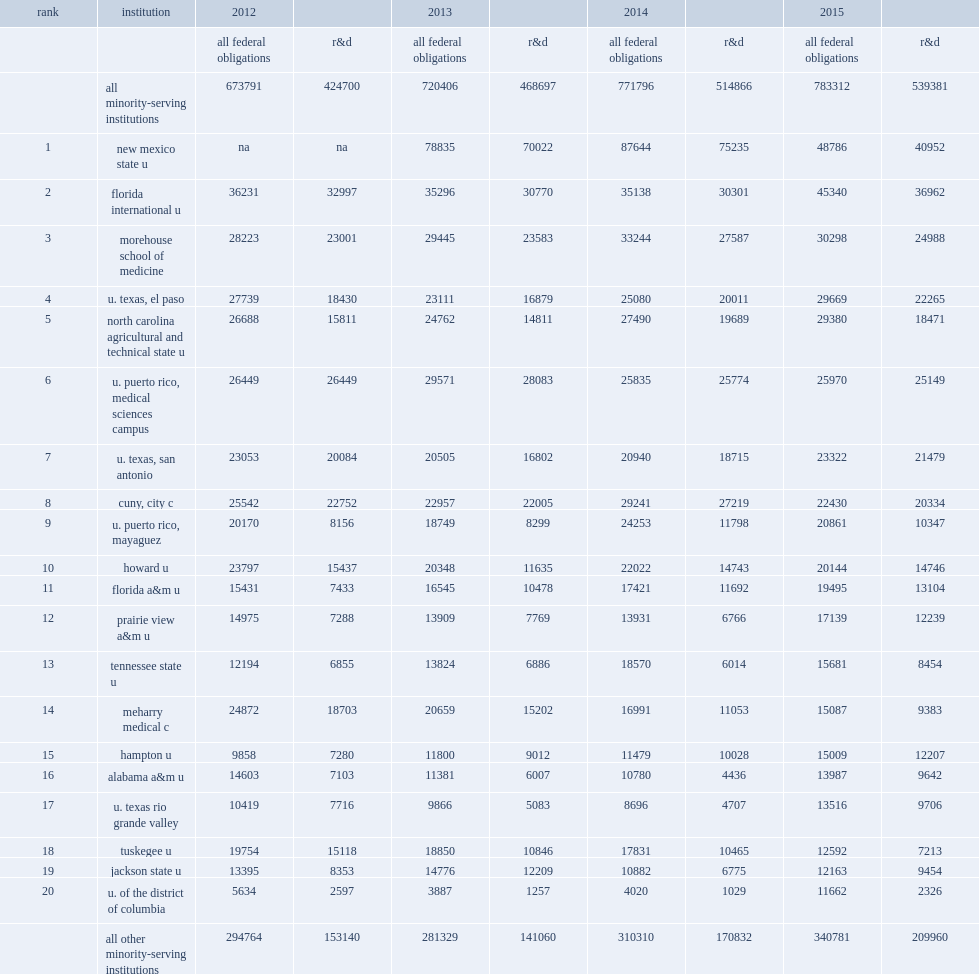New mexico state university, an hhe, was the leading msi recipient of federal s&e obligations, how many thousand dollars of receiving in fy 2015? 48786.0. New mexico state university, an hhe, was the leading msi recipient of federal s&e obligations, receiving $48.8 million in fy 2015, how many percent of which was for r&d? 0.839421. 